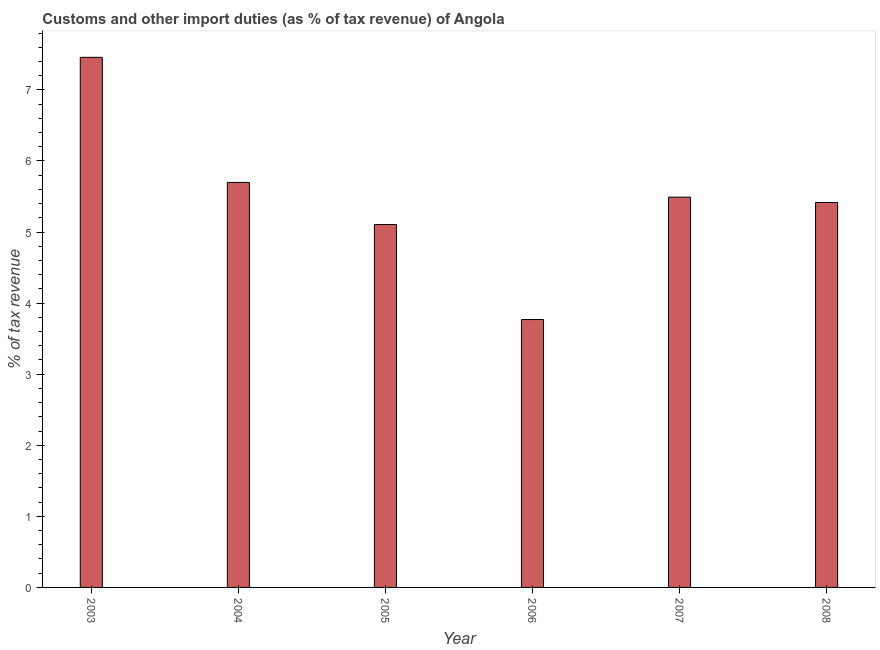Does the graph contain grids?
Your answer should be very brief. No. What is the title of the graph?
Your answer should be very brief. Customs and other import duties (as % of tax revenue) of Angola. What is the label or title of the Y-axis?
Make the answer very short. % of tax revenue. What is the customs and other import duties in 2004?
Ensure brevity in your answer.  5.7. Across all years, what is the maximum customs and other import duties?
Your answer should be very brief. 7.46. Across all years, what is the minimum customs and other import duties?
Offer a very short reply. 3.77. What is the sum of the customs and other import duties?
Give a very brief answer. 32.94. What is the difference between the customs and other import duties in 2004 and 2008?
Make the answer very short. 0.28. What is the average customs and other import duties per year?
Keep it short and to the point. 5.49. What is the median customs and other import duties?
Give a very brief answer. 5.45. Do a majority of the years between 2006 and 2004 (inclusive) have customs and other import duties greater than 3.8 %?
Your answer should be compact. Yes. What is the ratio of the customs and other import duties in 2005 to that in 2006?
Your response must be concise. 1.35. Is the customs and other import duties in 2005 less than that in 2008?
Offer a very short reply. Yes. What is the difference between the highest and the second highest customs and other import duties?
Provide a succinct answer. 1.76. What is the difference between the highest and the lowest customs and other import duties?
Offer a very short reply. 3.69. In how many years, is the customs and other import duties greater than the average customs and other import duties taken over all years?
Ensure brevity in your answer.  3. How many bars are there?
Your answer should be compact. 6. Are all the bars in the graph horizontal?
Keep it short and to the point. No. How many years are there in the graph?
Make the answer very short. 6. Are the values on the major ticks of Y-axis written in scientific E-notation?
Offer a terse response. No. What is the % of tax revenue in 2003?
Provide a succinct answer. 7.46. What is the % of tax revenue in 2004?
Give a very brief answer. 5.7. What is the % of tax revenue in 2005?
Your answer should be very brief. 5.11. What is the % of tax revenue of 2006?
Offer a terse response. 3.77. What is the % of tax revenue in 2007?
Your answer should be very brief. 5.49. What is the % of tax revenue in 2008?
Ensure brevity in your answer.  5.42. What is the difference between the % of tax revenue in 2003 and 2004?
Provide a short and direct response. 1.76. What is the difference between the % of tax revenue in 2003 and 2005?
Your answer should be very brief. 2.35. What is the difference between the % of tax revenue in 2003 and 2006?
Keep it short and to the point. 3.69. What is the difference between the % of tax revenue in 2003 and 2007?
Offer a very short reply. 1.97. What is the difference between the % of tax revenue in 2003 and 2008?
Offer a very short reply. 2.04. What is the difference between the % of tax revenue in 2004 and 2005?
Keep it short and to the point. 0.59. What is the difference between the % of tax revenue in 2004 and 2006?
Provide a succinct answer. 1.93. What is the difference between the % of tax revenue in 2004 and 2007?
Make the answer very short. 0.21. What is the difference between the % of tax revenue in 2004 and 2008?
Give a very brief answer. 0.28. What is the difference between the % of tax revenue in 2005 and 2006?
Keep it short and to the point. 1.34. What is the difference between the % of tax revenue in 2005 and 2007?
Provide a succinct answer. -0.39. What is the difference between the % of tax revenue in 2005 and 2008?
Ensure brevity in your answer.  -0.31. What is the difference between the % of tax revenue in 2006 and 2007?
Your answer should be compact. -1.72. What is the difference between the % of tax revenue in 2006 and 2008?
Keep it short and to the point. -1.65. What is the difference between the % of tax revenue in 2007 and 2008?
Ensure brevity in your answer.  0.08. What is the ratio of the % of tax revenue in 2003 to that in 2004?
Your response must be concise. 1.31. What is the ratio of the % of tax revenue in 2003 to that in 2005?
Keep it short and to the point. 1.46. What is the ratio of the % of tax revenue in 2003 to that in 2006?
Provide a short and direct response. 1.98. What is the ratio of the % of tax revenue in 2003 to that in 2007?
Your answer should be very brief. 1.36. What is the ratio of the % of tax revenue in 2003 to that in 2008?
Provide a short and direct response. 1.38. What is the ratio of the % of tax revenue in 2004 to that in 2005?
Offer a very short reply. 1.12. What is the ratio of the % of tax revenue in 2004 to that in 2006?
Give a very brief answer. 1.51. What is the ratio of the % of tax revenue in 2004 to that in 2007?
Make the answer very short. 1.04. What is the ratio of the % of tax revenue in 2004 to that in 2008?
Offer a very short reply. 1.05. What is the ratio of the % of tax revenue in 2005 to that in 2006?
Your answer should be compact. 1.35. What is the ratio of the % of tax revenue in 2005 to that in 2008?
Ensure brevity in your answer.  0.94. What is the ratio of the % of tax revenue in 2006 to that in 2007?
Your answer should be very brief. 0.69. What is the ratio of the % of tax revenue in 2006 to that in 2008?
Keep it short and to the point. 0.7. 